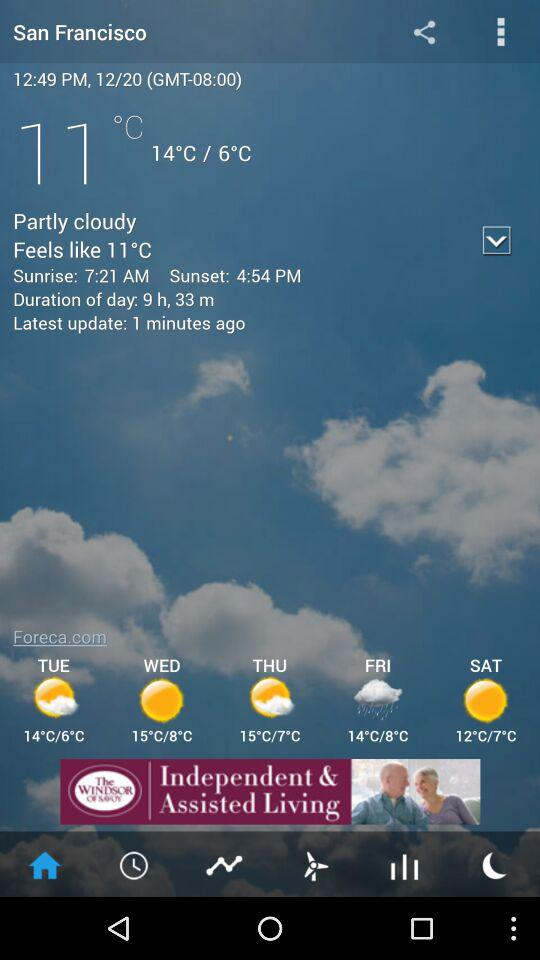How many hours are there between sunrise and sunset?
Answer the question using a single word or phrase. 9 h, 33 m 